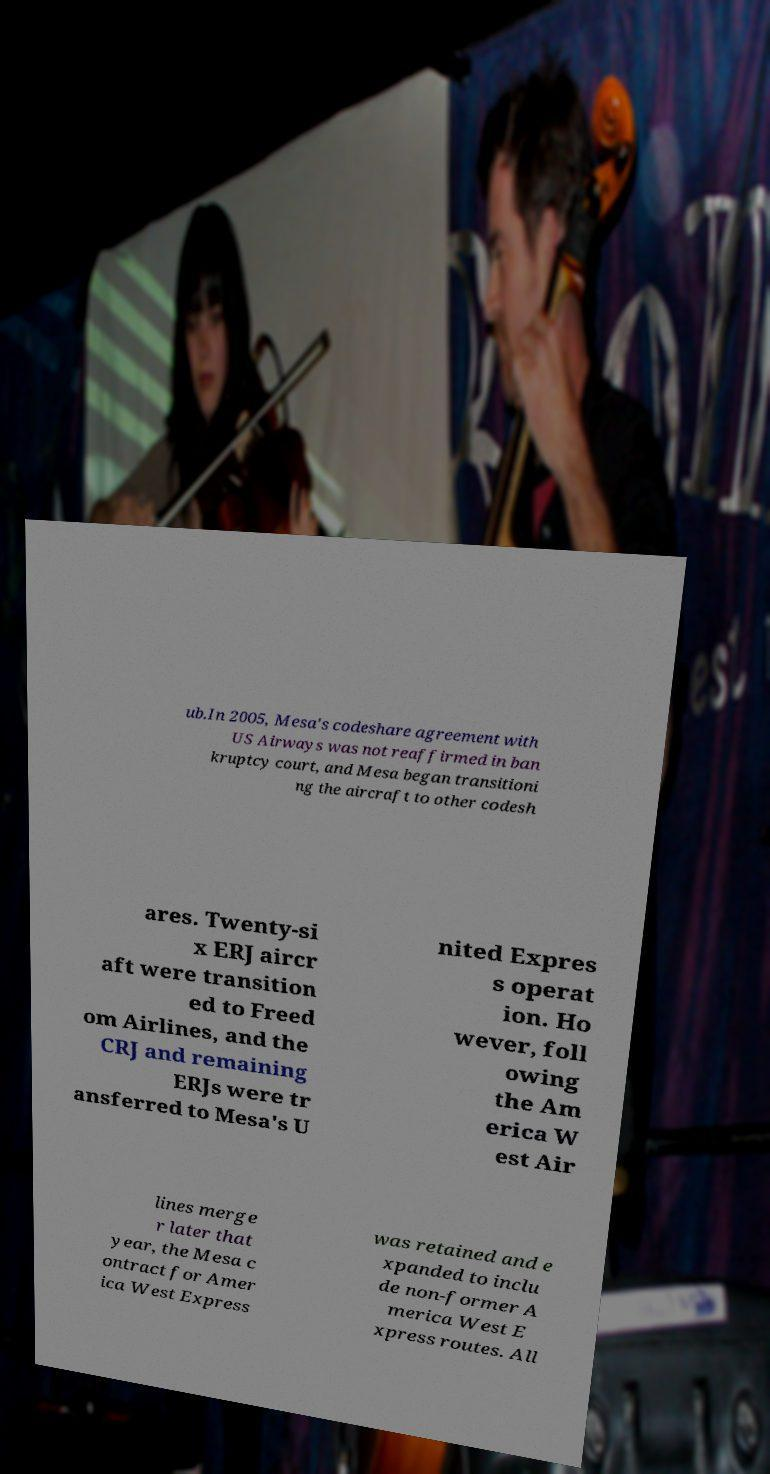Could you assist in decoding the text presented in this image and type it out clearly? ub.In 2005, Mesa's codeshare agreement with US Airways was not reaffirmed in ban kruptcy court, and Mesa began transitioni ng the aircraft to other codesh ares. Twenty-si x ERJ aircr aft were transition ed to Freed om Airlines, and the CRJ and remaining ERJs were tr ansferred to Mesa's U nited Expres s operat ion. Ho wever, foll owing the Am erica W est Air lines merge r later that year, the Mesa c ontract for Amer ica West Express was retained and e xpanded to inclu de non-former A merica West E xpress routes. All 